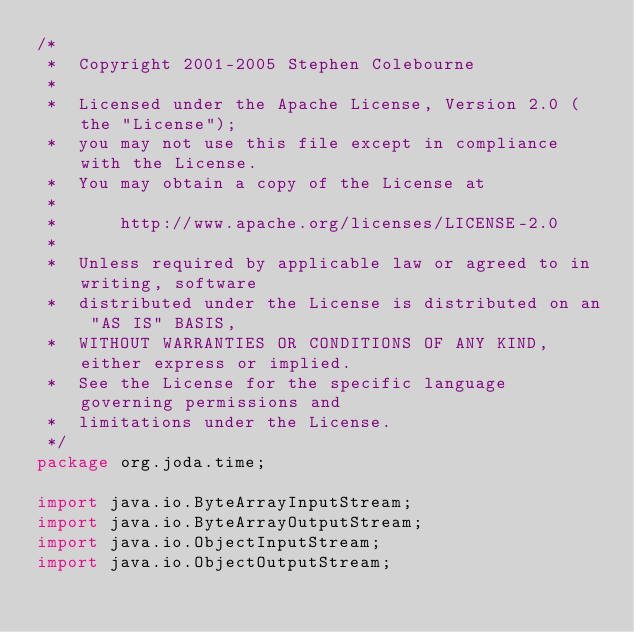<code> <loc_0><loc_0><loc_500><loc_500><_Java_>/*
 *  Copyright 2001-2005 Stephen Colebourne
 *
 *  Licensed under the Apache License, Version 2.0 (the "License");
 *  you may not use this file except in compliance with the License.
 *  You may obtain a copy of the License at
 *
 *      http://www.apache.org/licenses/LICENSE-2.0
 *
 *  Unless required by applicable law or agreed to in writing, software
 *  distributed under the License is distributed on an "AS IS" BASIS,
 *  WITHOUT WARRANTIES OR CONDITIONS OF ANY KIND, either express or implied.
 *  See the License for the specific language governing permissions and
 *  limitations under the License.
 */
package org.joda.time;

import java.io.ByteArrayInputStream;
import java.io.ByteArrayOutputStream;
import java.io.ObjectInputStream;
import java.io.ObjectOutputStream;</code> 